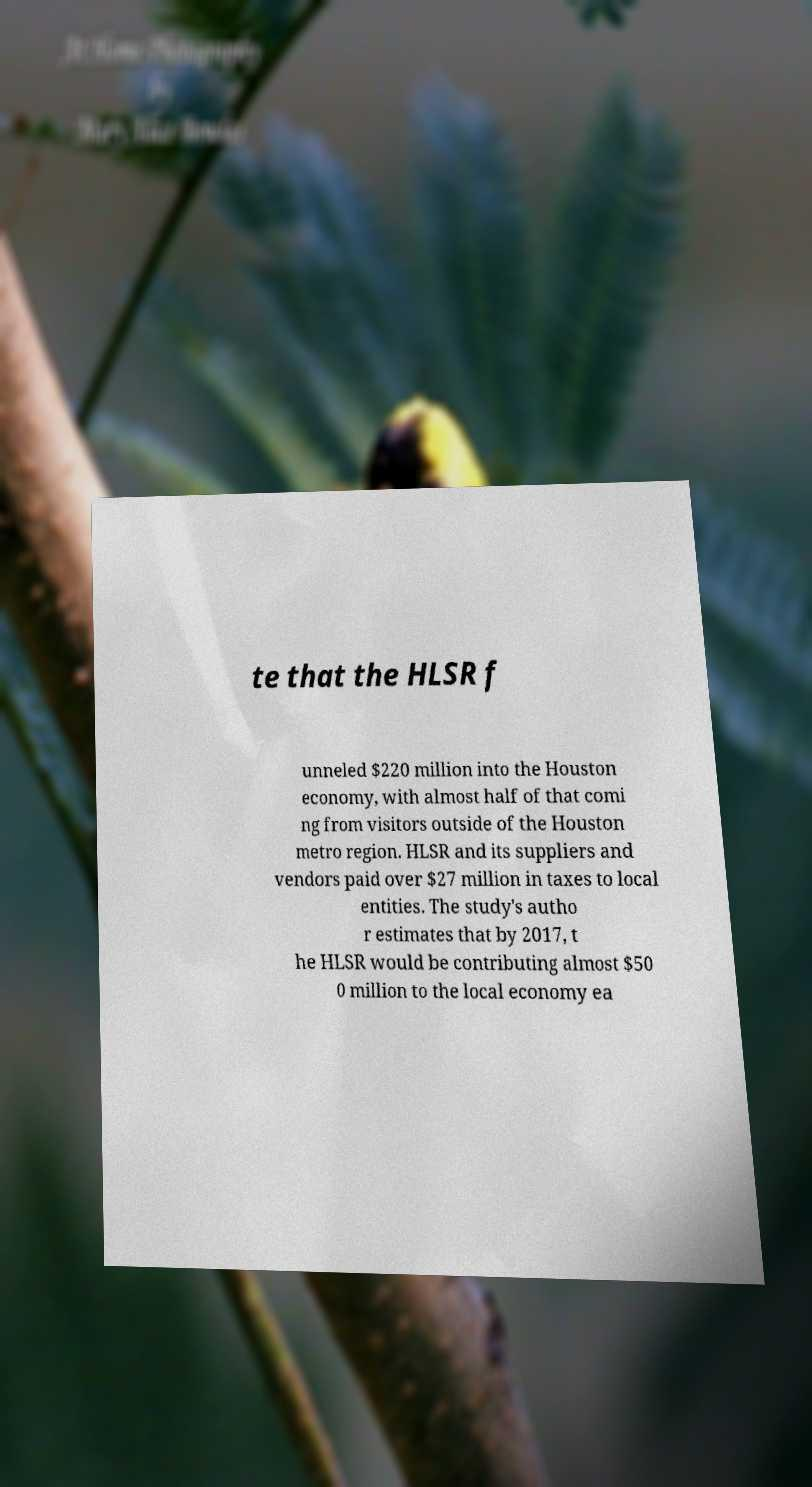Could you extract and type out the text from this image? te that the HLSR f unneled $220 million into the Houston economy, with almost half of that comi ng from visitors outside of the Houston metro region. HLSR and its suppliers and vendors paid over $27 million in taxes to local entities. The study's autho r estimates that by 2017, t he HLSR would be contributing almost $50 0 million to the local economy ea 